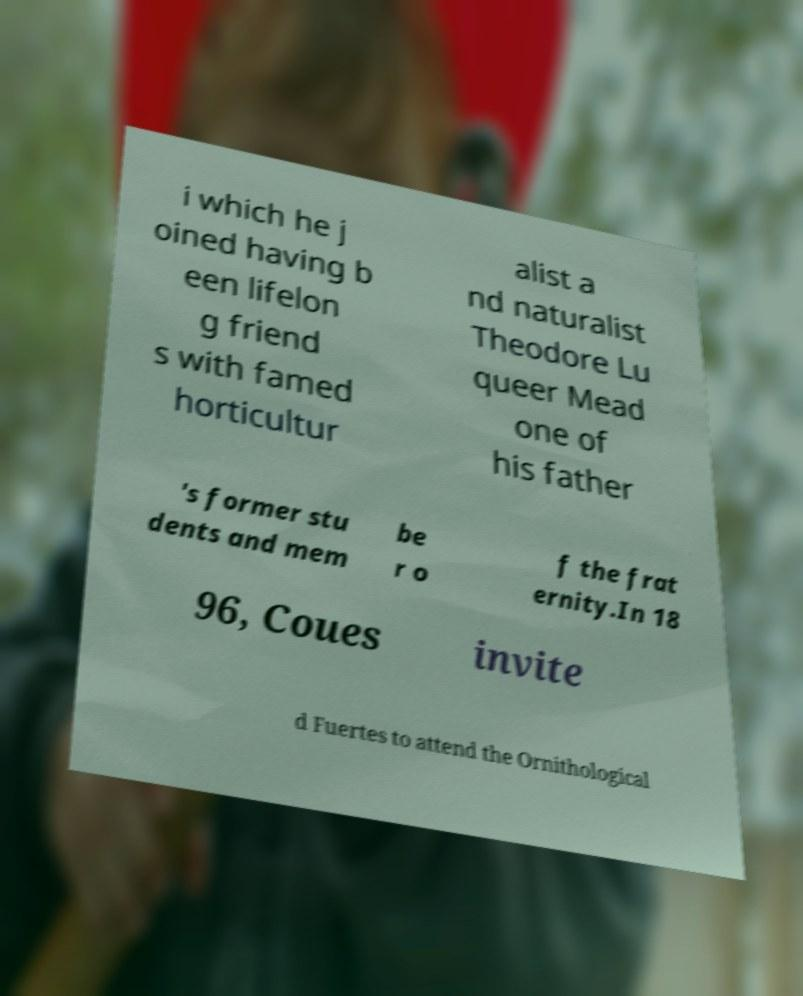Could you extract and type out the text from this image? i which he j oined having b een lifelon g friend s with famed horticultur alist a nd naturalist Theodore Lu queer Mead one of his father 's former stu dents and mem be r o f the frat ernity.In 18 96, Coues invite d Fuertes to attend the Ornithological 